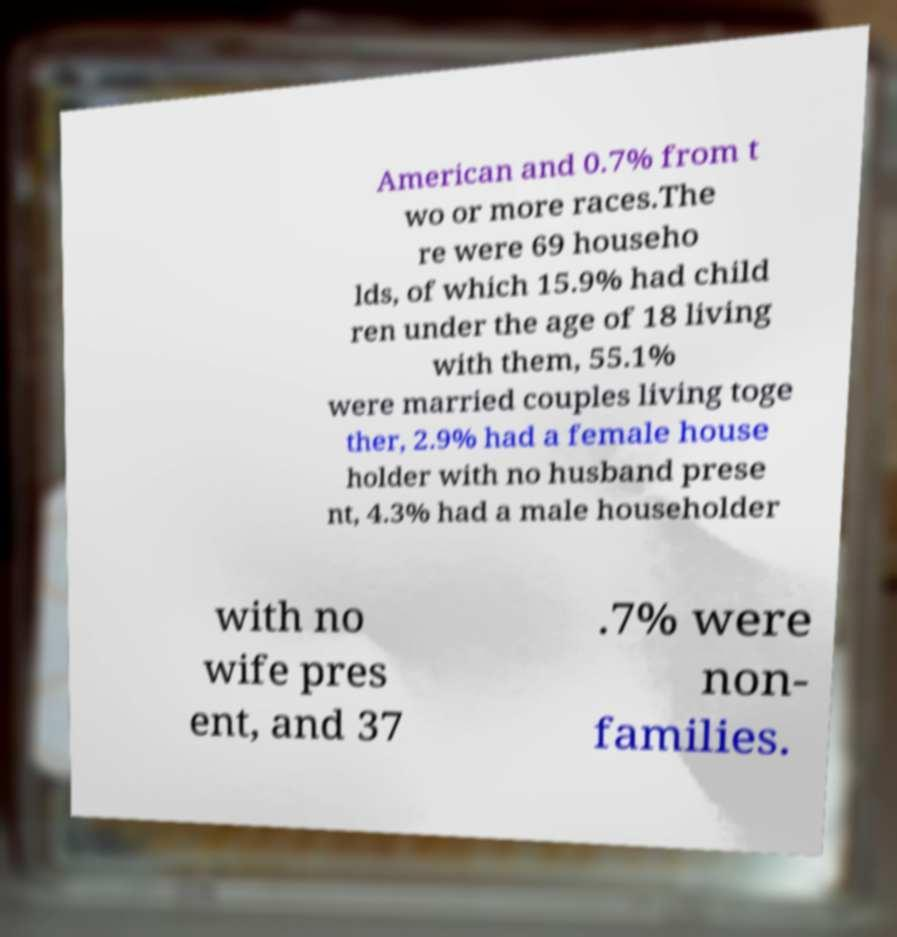Please identify and transcribe the text found in this image. American and 0.7% from t wo or more races.The re were 69 househo lds, of which 15.9% had child ren under the age of 18 living with them, 55.1% were married couples living toge ther, 2.9% had a female house holder with no husband prese nt, 4.3% had a male householder with no wife pres ent, and 37 .7% were non- families. 